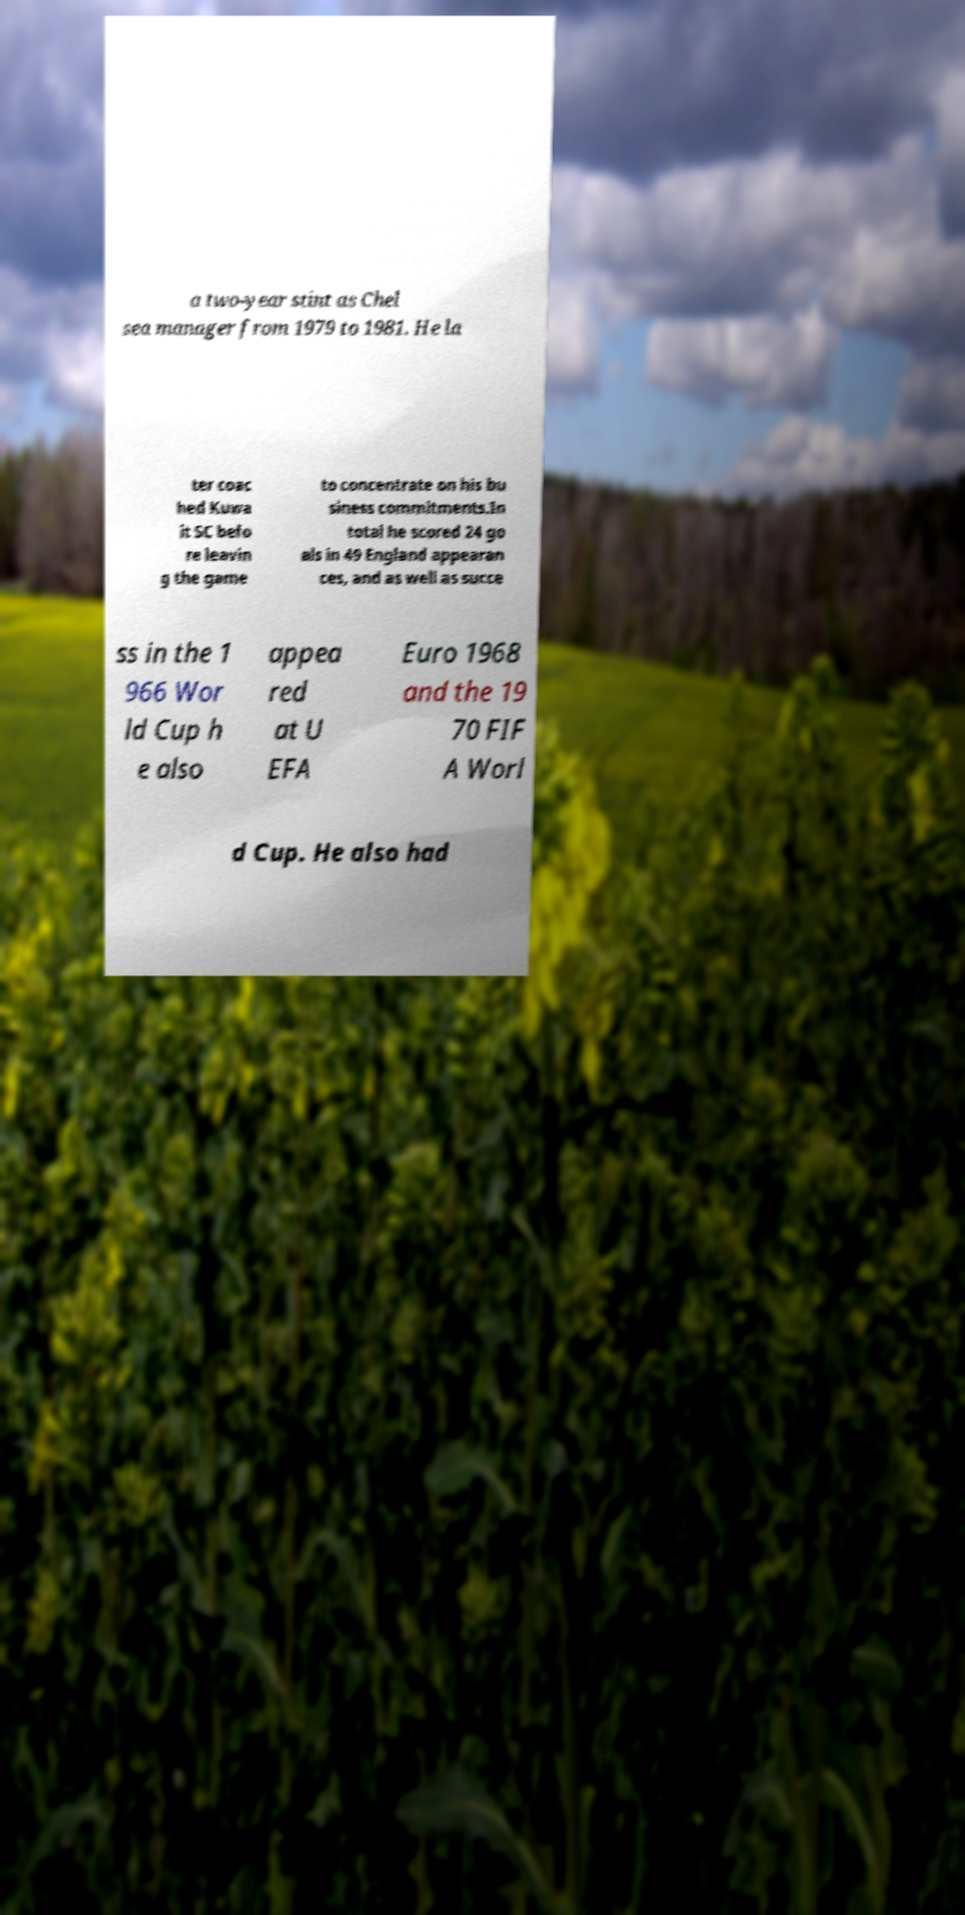For documentation purposes, I need the text within this image transcribed. Could you provide that? a two-year stint as Chel sea manager from 1979 to 1981. He la ter coac hed Kuwa it SC befo re leavin g the game to concentrate on his bu siness commitments.In total he scored 24 go als in 49 England appearan ces, and as well as succe ss in the 1 966 Wor ld Cup h e also appea red at U EFA Euro 1968 and the 19 70 FIF A Worl d Cup. He also had 